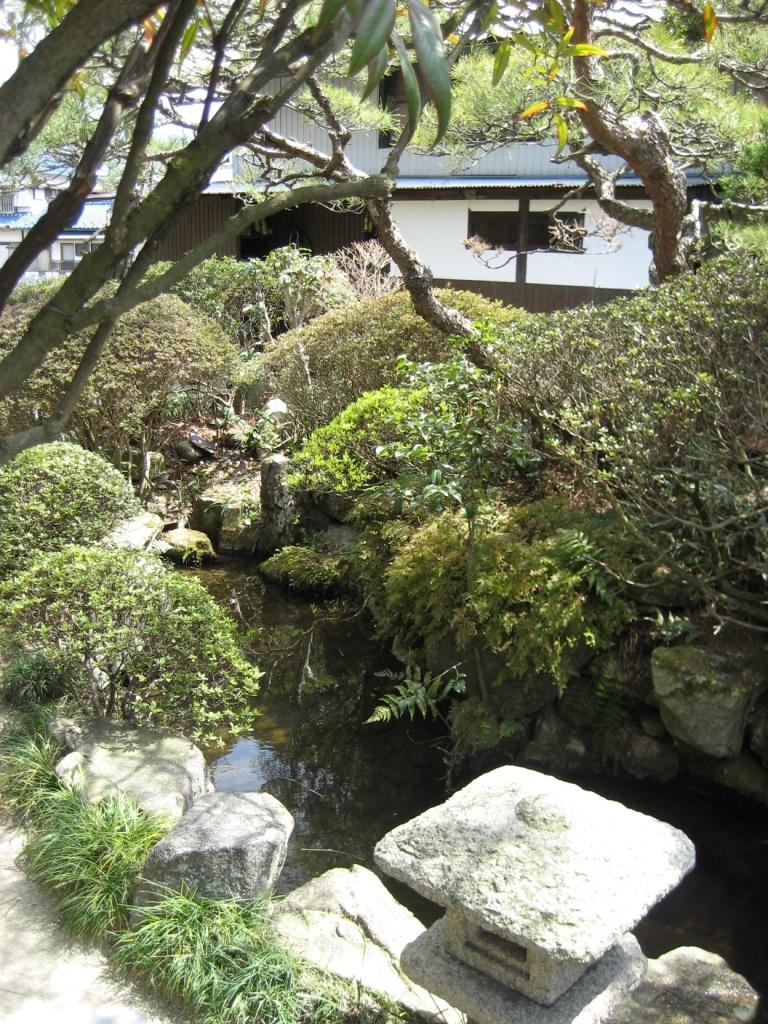What type of structure is in the image? There is a building in the image. What other natural elements can be seen in the image? Plants, water, rocks, and trees are present in the image. Can you describe the branches visible in the image? The branches of a tree are visible in the image. How many trees are in the group of trees visible in the image? There is a group of trees in the image, but the exact number is not specified. What part of the natural environment is visible in the image? The sky is visible in the image. What type of beef is being served at the train station in the image? There is no train station or beef present in the image. What type of land can be seen in the image? The image does not specifically show land; it features a building, plants, water, rocks, trees, and the sky. 